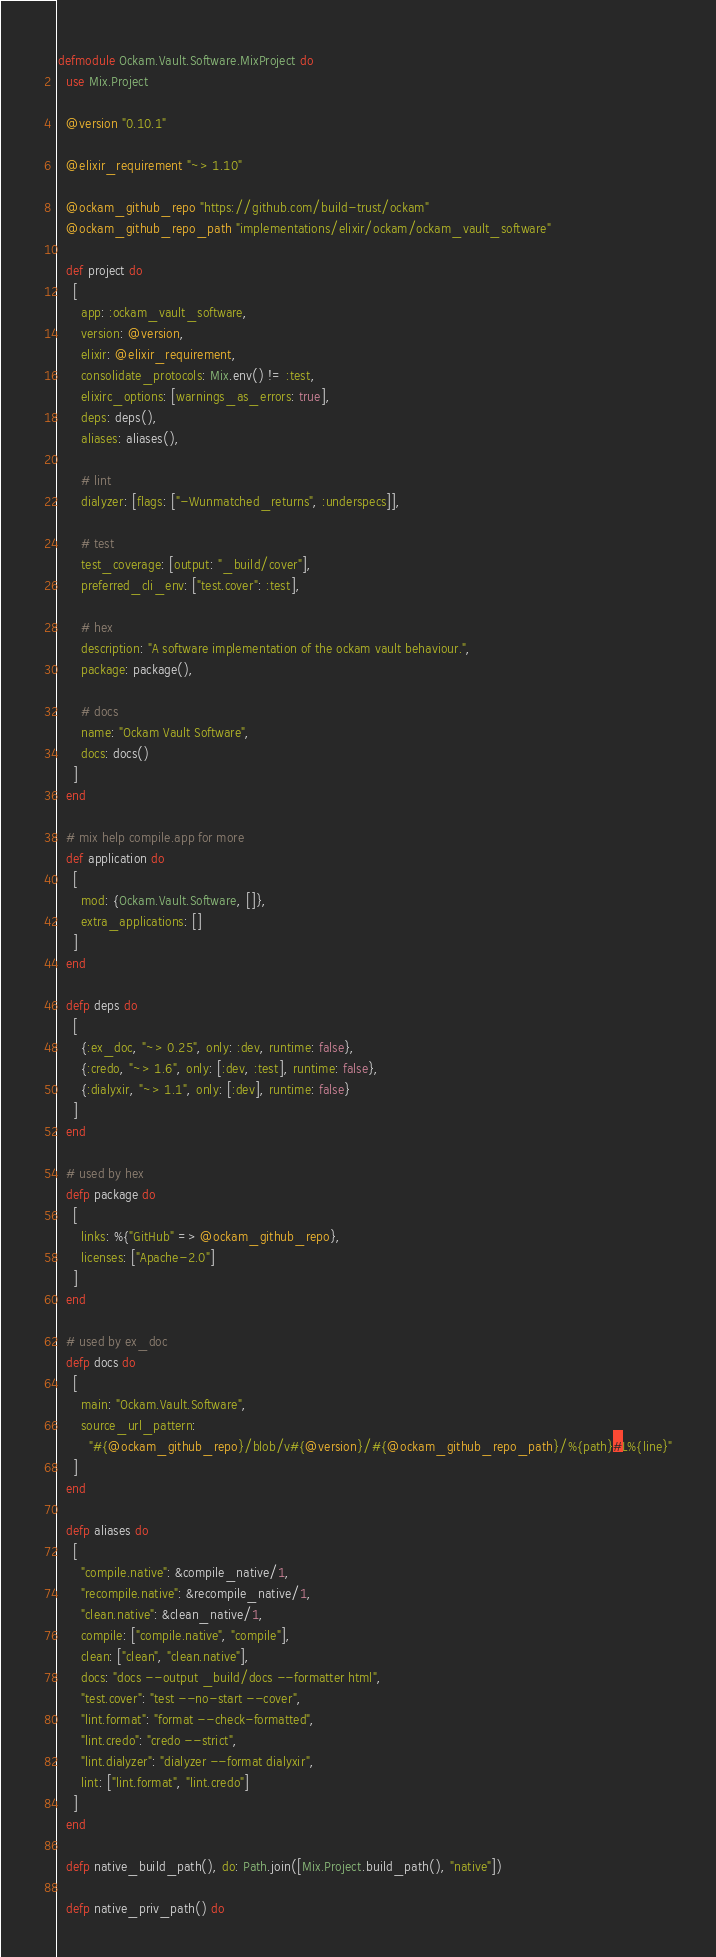<code> <loc_0><loc_0><loc_500><loc_500><_Elixir_>defmodule Ockam.Vault.Software.MixProject do
  use Mix.Project

  @version "0.10.1"

  @elixir_requirement "~> 1.10"

  @ockam_github_repo "https://github.com/build-trust/ockam"
  @ockam_github_repo_path "implementations/elixir/ockam/ockam_vault_software"

  def project do
    [
      app: :ockam_vault_software,
      version: @version,
      elixir: @elixir_requirement,
      consolidate_protocols: Mix.env() != :test,
      elixirc_options: [warnings_as_errors: true],
      deps: deps(),
      aliases: aliases(),

      # lint
      dialyzer: [flags: ["-Wunmatched_returns", :underspecs]],

      # test
      test_coverage: [output: "_build/cover"],
      preferred_cli_env: ["test.cover": :test],

      # hex
      description: "A software implementation of the ockam vault behaviour.",
      package: package(),

      # docs
      name: "Ockam Vault Software",
      docs: docs()
    ]
  end

  # mix help compile.app for more
  def application do
    [
      mod: {Ockam.Vault.Software, []},
      extra_applications: []
    ]
  end

  defp deps do
    [
      {:ex_doc, "~> 0.25", only: :dev, runtime: false},
      {:credo, "~> 1.6", only: [:dev, :test], runtime: false},
      {:dialyxir, "~> 1.1", only: [:dev], runtime: false}
    ]
  end

  # used by hex
  defp package do
    [
      links: %{"GitHub" => @ockam_github_repo},
      licenses: ["Apache-2.0"]
    ]
  end

  # used by ex_doc
  defp docs do
    [
      main: "Ockam.Vault.Software",
      source_url_pattern:
        "#{@ockam_github_repo}/blob/v#{@version}/#{@ockam_github_repo_path}/%{path}#L%{line}"
    ]
  end

  defp aliases do
    [
      "compile.native": &compile_native/1,
      "recompile.native": &recompile_native/1,
      "clean.native": &clean_native/1,
      compile: ["compile.native", "compile"],
      clean: ["clean", "clean.native"],
      docs: "docs --output _build/docs --formatter html",
      "test.cover": "test --no-start --cover",
      "lint.format": "format --check-formatted",
      "lint.credo": "credo --strict",
      "lint.dialyzer": "dialyzer --format dialyxir",
      lint: ["lint.format", "lint.credo"]
    ]
  end

  defp native_build_path(), do: Path.join([Mix.Project.build_path(), "native"])

  defp native_priv_path() do</code> 